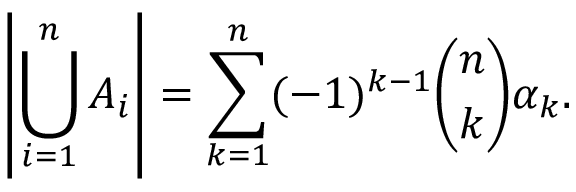Convert formula to latex. <formula><loc_0><loc_0><loc_500><loc_500>\left | \bigcup _ { i = 1 } ^ { n } A _ { i } \right | = \sum _ { k = 1 } ^ { n } ( - 1 ) ^ { k - 1 } { \binom { n } { k } } \alpha _ { k } .</formula> 